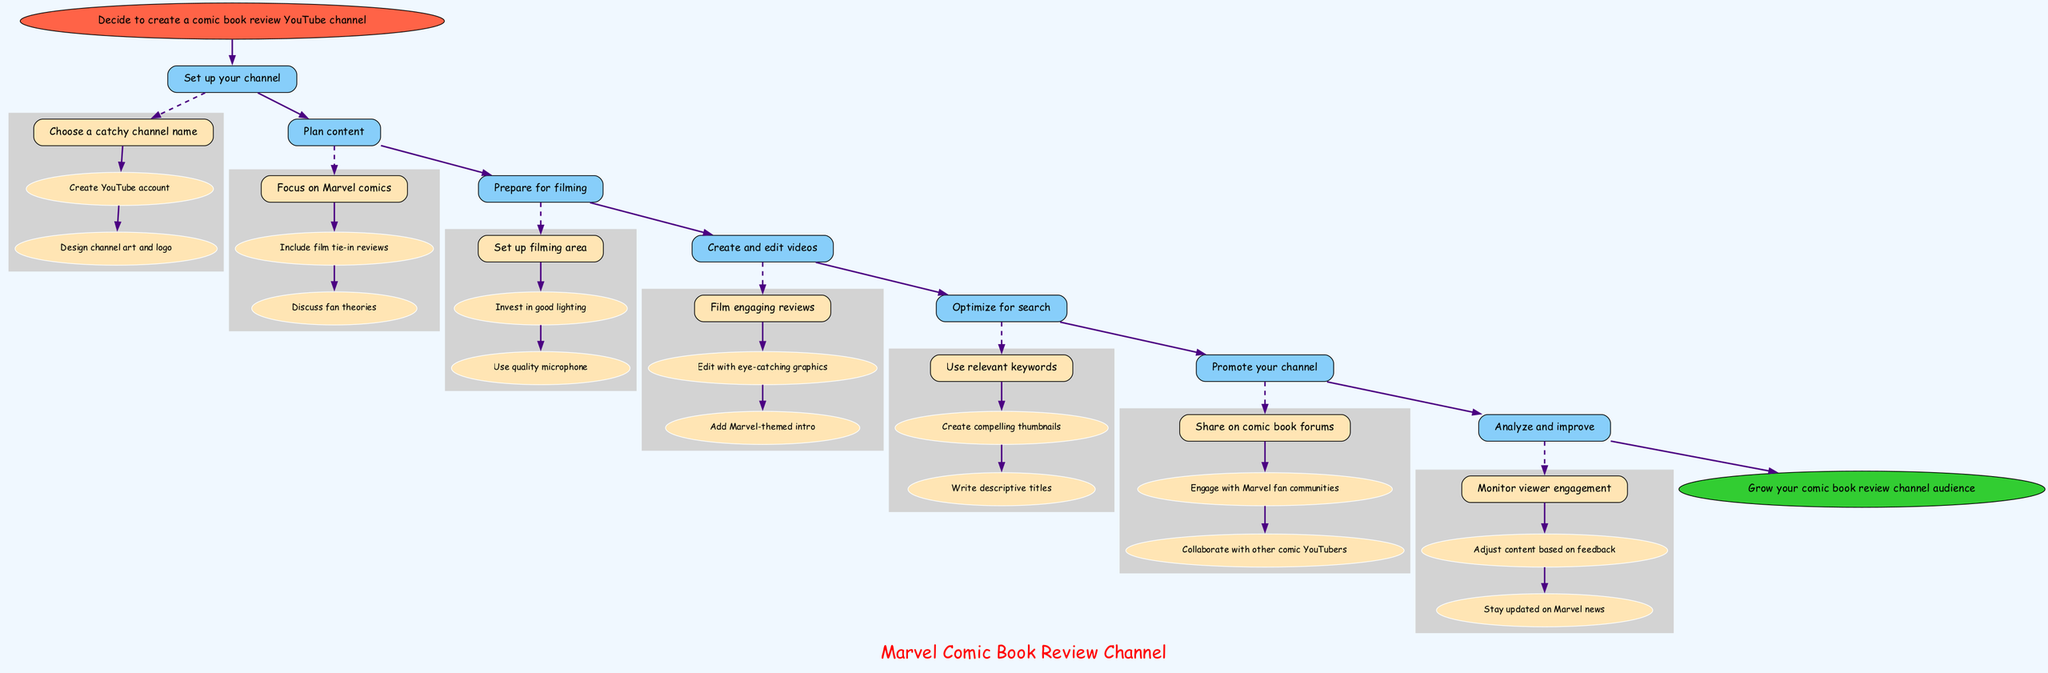What is the first step in the process? The first step labeled in the diagram is connected to the start node, which states "Decide to create a comic book review YouTube channel."
Answer: Decide to create a comic book review YouTube channel How many main steps are there in the diagram? The diagram lists seven main steps, each connected to the previous step by directed edges. By counting them, we see that there are seven steps in total.
Answer: 7 What is the last step before finishing the process? The last main step in the flow chart before reaching the end node is "Analyze and improve," which is directly connected to the last node in the process.
Answer: Analyze and improve Which substep comes first in "Plan content"? In the "Plan content" step, the first substep listed is "Focus on Marvel comics." This can be identified by its position among the substeps outlined under that main step.
Answer: Focus on Marvel comics What is the relationship between "Optimize for search" and "Promote your channel"? "Optimize for search" comes directly before "Promote your channel" in the sequence of steps, indicating a linear progression where the former is a prerequisite for the latter in the workflow.
Answer: Linear progression How many substeps are in the "Prepare for filming" section? The "Prepare for filming" section has three substeps listed, each of which can be counted by looking at the enumeration under that main step.
Answer: 3 What is the primary focus of the content planned in the channel? The primary focus indicated in the "Plan content" step is "Marvel comics," as it is specifically stated as the first substep under that category.
Answer: Marvel comics What type of microphone is recommended for preparation? The substep in "Prepare for filming" specifies that the type of microphone should be of quality, as stated in the list of requirements.
Answer: Quality microphone 